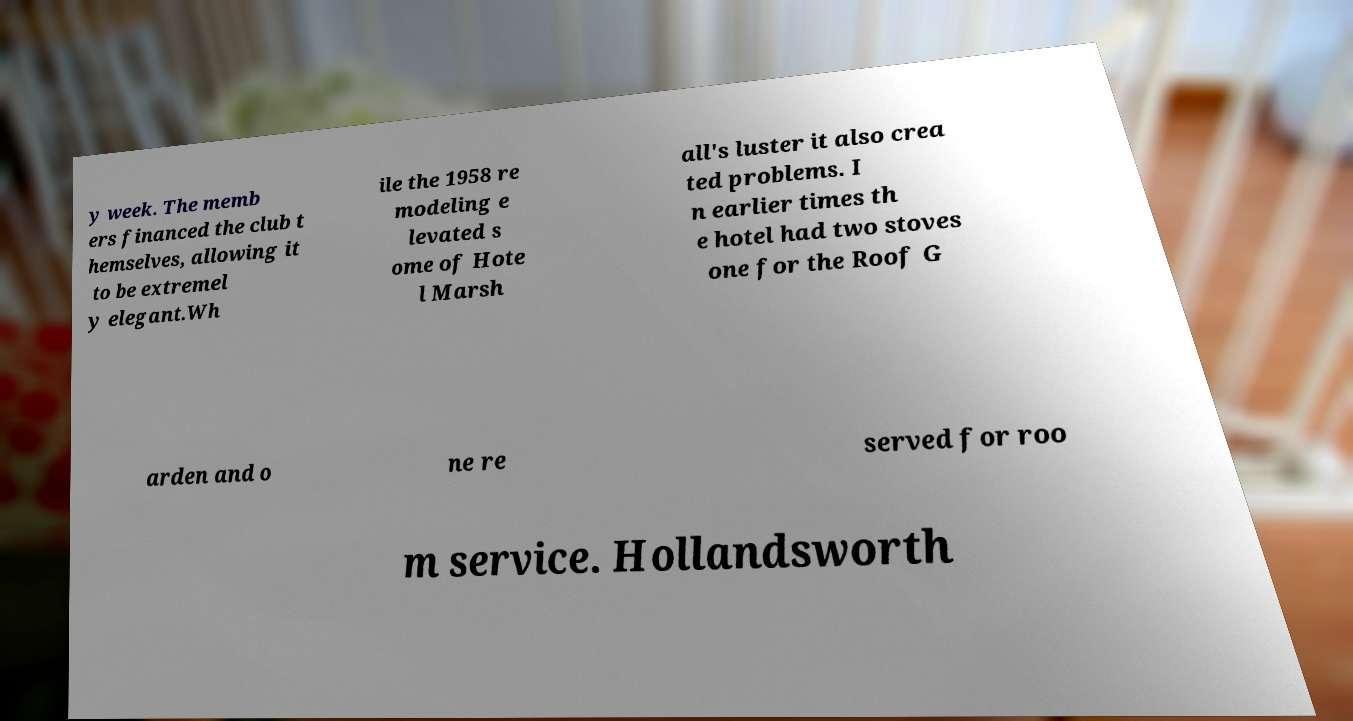Please identify and transcribe the text found in this image. y week. The memb ers financed the club t hemselves, allowing it to be extremel y elegant.Wh ile the 1958 re modeling e levated s ome of Hote l Marsh all's luster it also crea ted problems. I n earlier times th e hotel had two stoves one for the Roof G arden and o ne re served for roo m service. Hollandsworth 